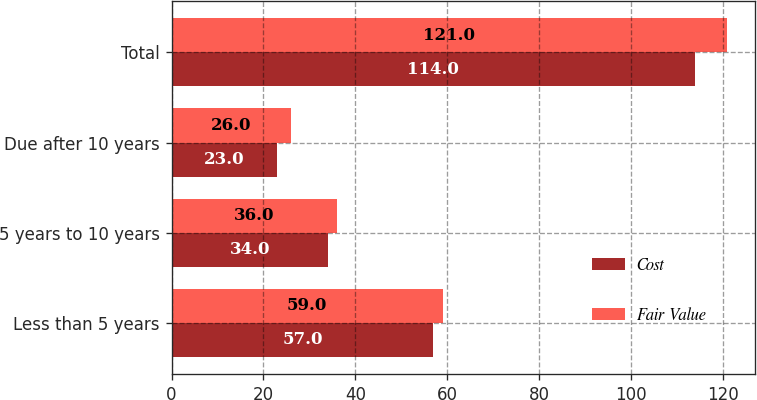Convert chart. <chart><loc_0><loc_0><loc_500><loc_500><stacked_bar_chart><ecel><fcel>Less than 5 years<fcel>5 years to 10 years<fcel>Due after 10 years<fcel>Total<nl><fcel>Cost<fcel>57<fcel>34<fcel>23<fcel>114<nl><fcel>Fair Value<fcel>59<fcel>36<fcel>26<fcel>121<nl></chart> 